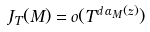Convert formula to latex. <formula><loc_0><loc_0><loc_500><loc_500>J _ { T } ( M ) = o ( T ^ { d \, \alpha _ { M } ( z ) } )</formula> 